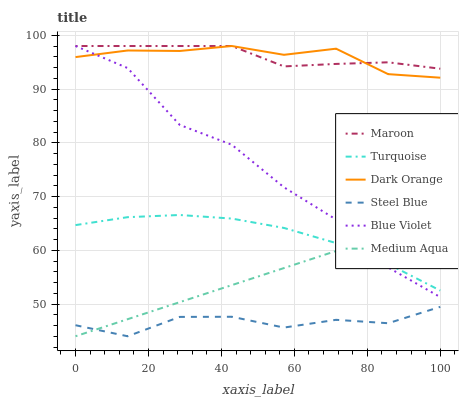Does Steel Blue have the minimum area under the curve?
Answer yes or no. Yes. Does Maroon have the maximum area under the curve?
Answer yes or no. Yes. Does Turquoise have the minimum area under the curve?
Answer yes or no. No. Does Turquoise have the maximum area under the curve?
Answer yes or no. No. Is Medium Aqua the smoothest?
Answer yes or no. Yes. Is Blue Violet the roughest?
Answer yes or no. Yes. Is Turquoise the smoothest?
Answer yes or no. No. Is Turquoise the roughest?
Answer yes or no. No. Does Steel Blue have the lowest value?
Answer yes or no. Yes. Does Turquoise have the lowest value?
Answer yes or no. No. Does Blue Violet have the highest value?
Answer yes or no. Yes. Does Turquoise have the highest value?
Answer yes or no. No. Is Steel Blue less than Turquoise?
Answer yes or no. Yes. Is Maroon greater than Medium Aqua?
Answer yes or no. Yes. Does Maroon intersect Dark Orange?
Answer yes or no. Yes. Is Maroon less than Dark Orange?
Answer yes or no. No. Is Maroon greater than Dark Orange?
Answer yes or no. No. Does Steel Blue intersect Turquoise?
Answer yes or no. No. 